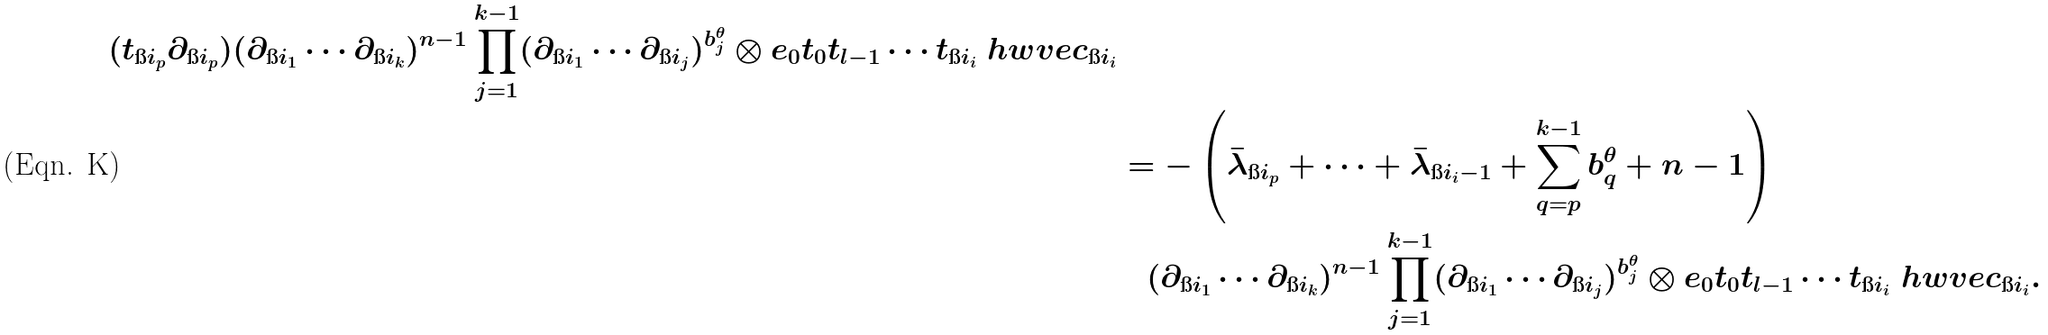Convert formula to latex. <formula><loc_0><loc_0><loc_500><loc_500>{ ( t _ { \i i _ { p } } \partial _ { \i i _ { p } } ) ( \partial _ { \i i _ { 1 } } \cdots \partial _ { \i i _ { k } } ) ^ { n - 1 } \prod _ { j = 1 } ^ { k - 1 } ( \partial _ { \i i _ { 1 } } \cdots \partial _ { \i i _ { j } } ) ^ { b ^ { \theta } _ { j } } \otimes e _ { 0 } t _ { 0 } t _ { l - 1 } \cdots t _ { \i i _ { i } } \ h w v e c _ { \i i _ { i } } } & \\ & = - \left ( \bar { \lambda } _ { \i i _ { p } } + \dots + \bar { \lambda } _ { \i i _ { i } - 1 } + \sum _ { q = p } ^ { k - 1 } b _ { q } ^ { \theta } + n - 1 \right ) \\ & \quad ( \partial _ { \i i _ { 1 } } \cdots \partial _ { \i i _ { k } } ) ^ { n - 1 } \prod _ { j = 1 } ^ { k - 1 } ( \partial _ { \i i _ { 1 } } \cdots \partial _ { \i i _ { j } } ) ^ { b ^ { \theta } _ { j } } \otimes e _ { 0 } t _ { 0 } t _ { l - 1 } \cdots t _ { \i i _ { i } } \ h w v e c _ { \i i _ { i } } .</formula> 